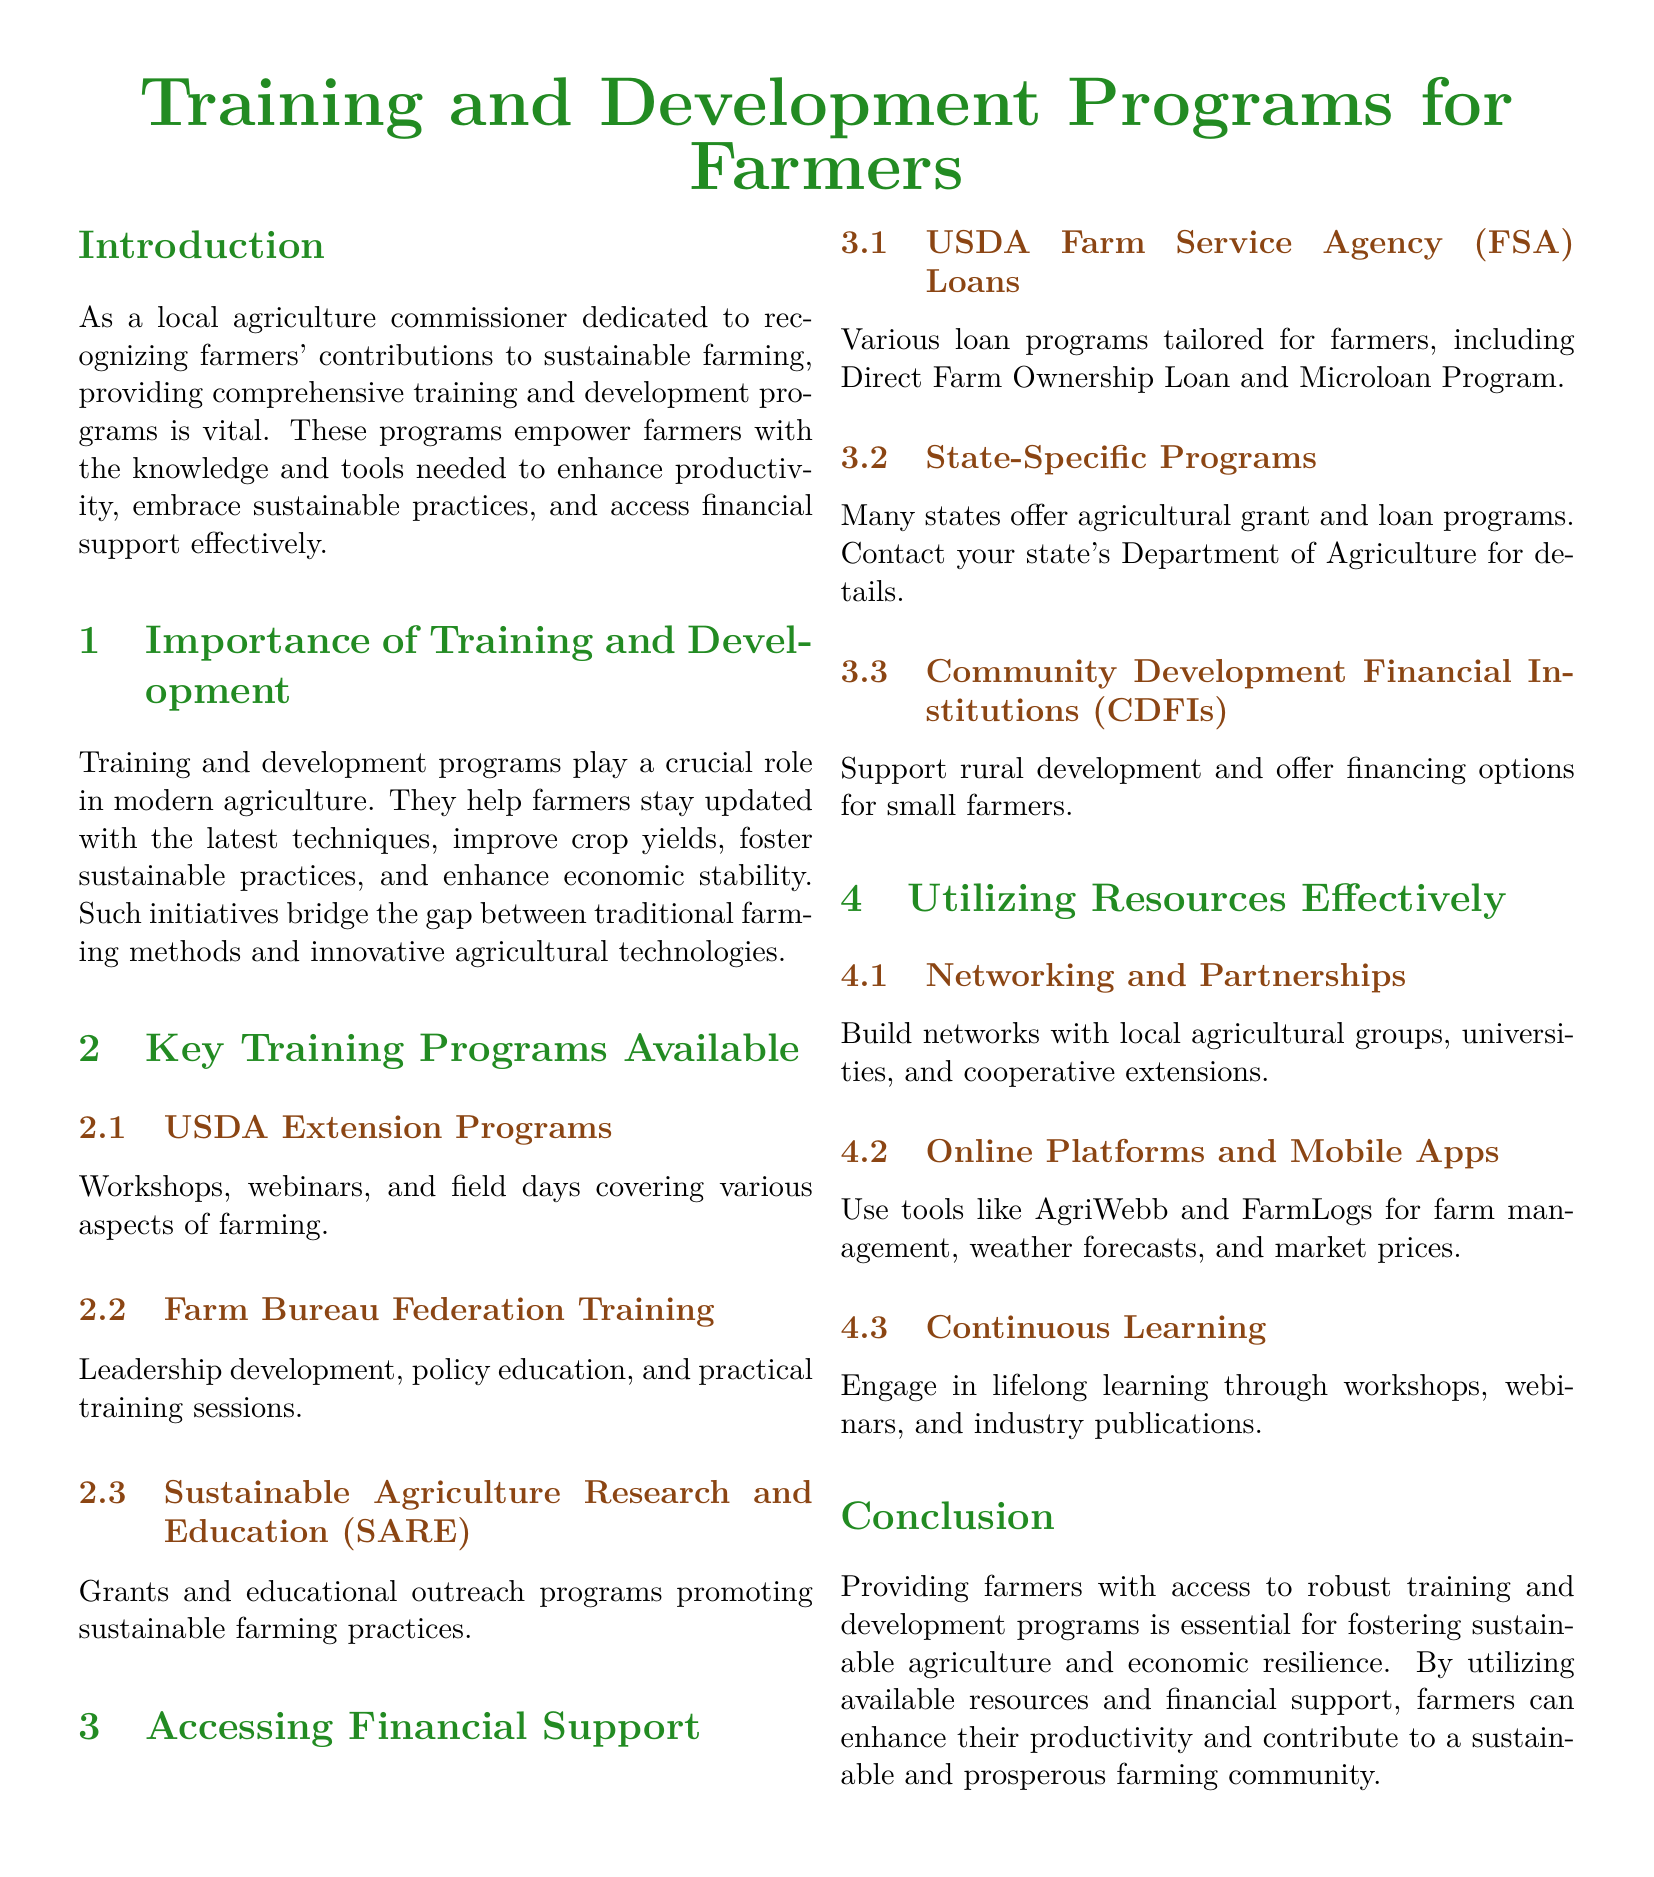What is the title of the document? The title is prominently displayed at the top of the document, indicating its content focus.
Answer: Training and Development Programs for Farmers What color is used for section titles? The document specifies the color scheme for section titles, helping to identify sections easily.
Answer: Farm green What type of programs does SARE promote? The document highlights specific programs available, detailing the focus of each.
Answer: Sustainable farming practices Which organization offers Direct Farm Ownership Loans? The document mentions specific organizations that provide financial support to farmers.
Answer: USDA Farm Service Agency What is one method for effectively utilizing resources? The document outlines various strategies for farmers to use available resources efficiently.
Answer: Networking and Partnerships How can farmers learn continuously according to the document? The document emphasizes the importance of ongoing education and methods to achieve it.
Answer: Workshops, webinars, and industry publications What is the role of USDA Extension Programs? The document describes the focus and content of various training programs available to farmers.
Answer: Workshops, webinars, and field days What is the aim of Community Development Financial Institutions? The document briefly mentions the purpose of this type of institution in relation to farmers.
Answer: Support rural development What does the conclusion of the document stress? The document wraps up by summarizing the key focus areas and importance of the discussed topics.
Answer: Access to robust training and development programs 